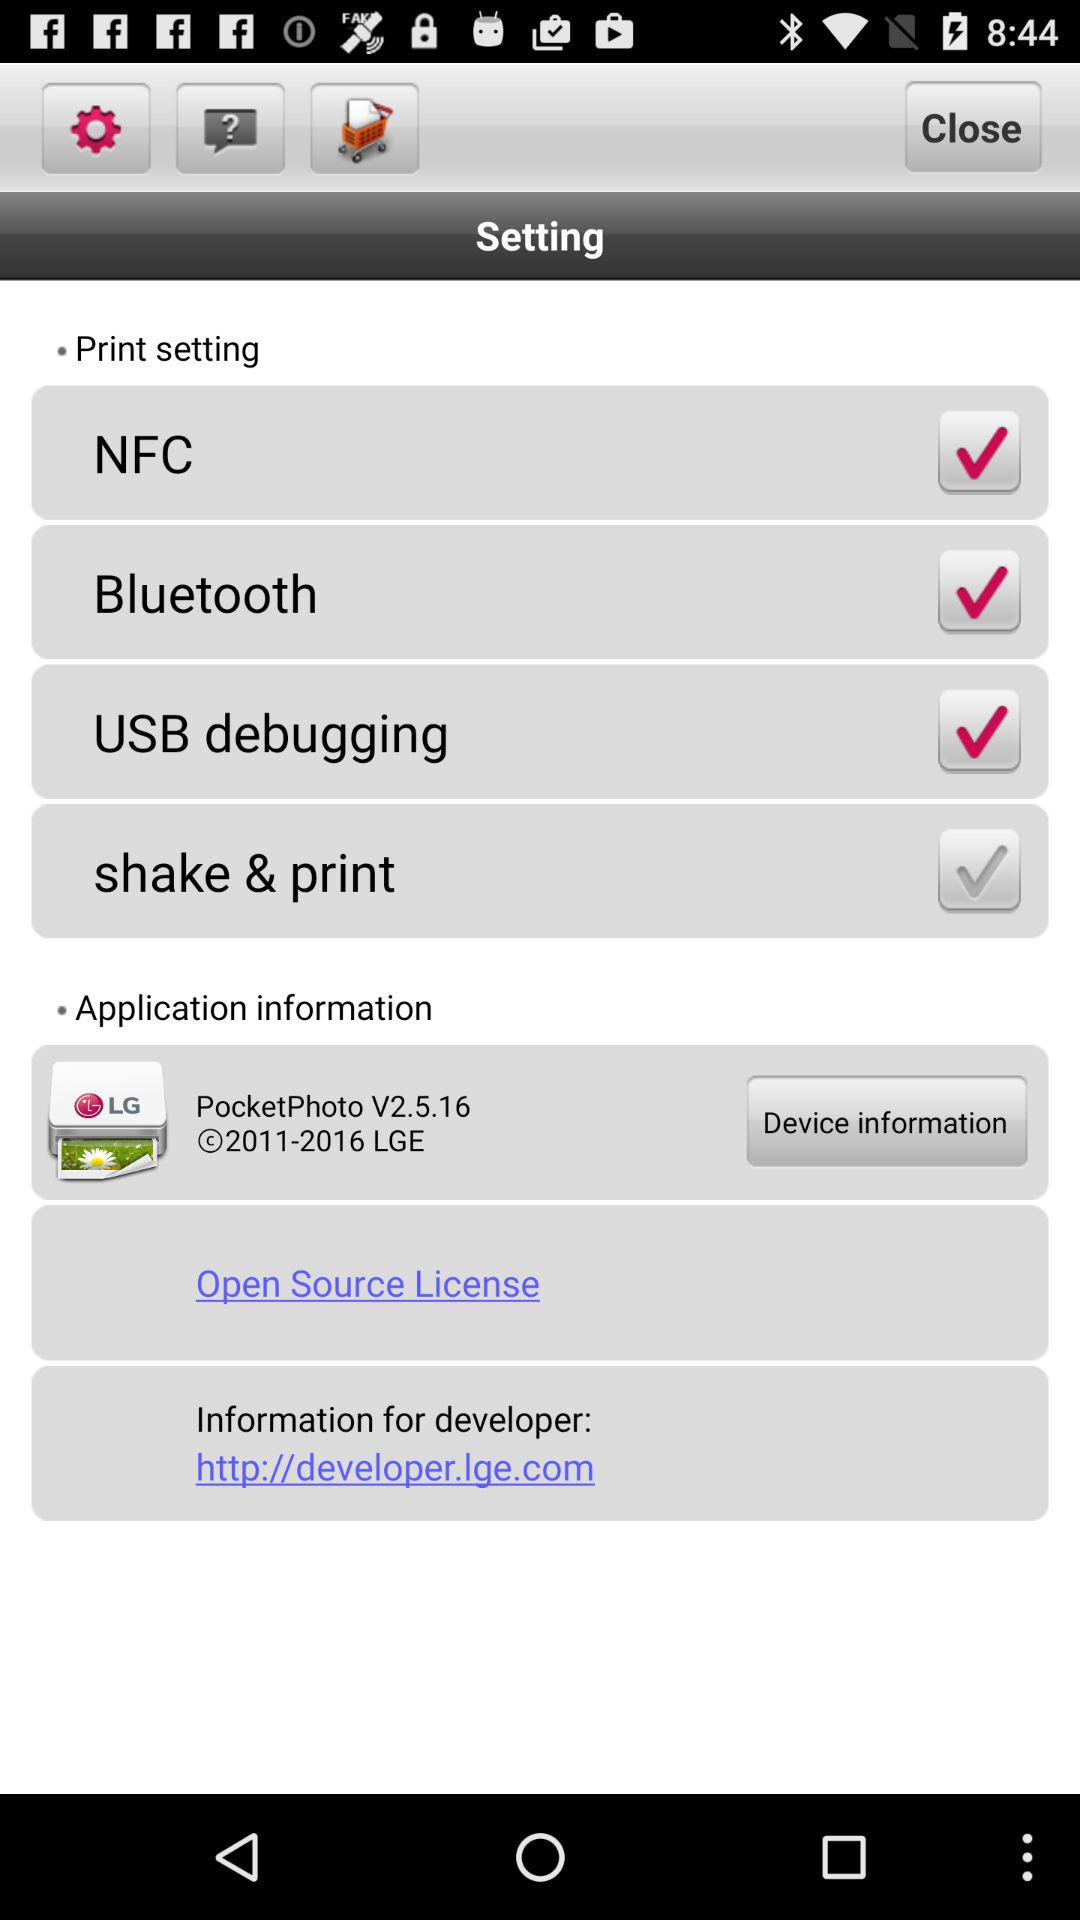What is the status of "shake & print"? The status of "shake & print" is "off". 